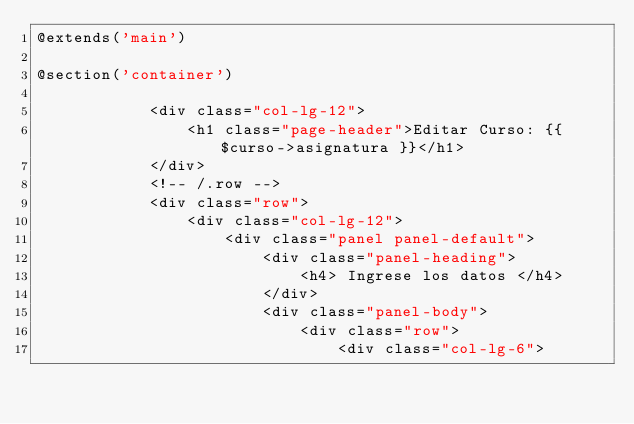<code> <loc_0><loc_0><loc_500><loc_500><_PHP_>@extends('main')

@section('container')

            <div class="col-lg-12">
                <h1 class="page-header">Editar Curso: {{ $curso->asignatura }}</h1>
            </div>
            <!-- /.row -->
            <div class="row">
                <div class="col-lg-12">
                    <div class="panel panel-default">
                        <div class="panel-heading">
                            <h4> Ingrese los datos </h4>
                        </div>
                        <div class="panel-body">
                            <div class="row">
                                <div class="col-lg-6"></code> 